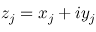Convert formula to latex. <formula><loc_0><loc_0><loc_500><loc_500>z _ { j } = x _ { j } + i y _ { j }</formula> 